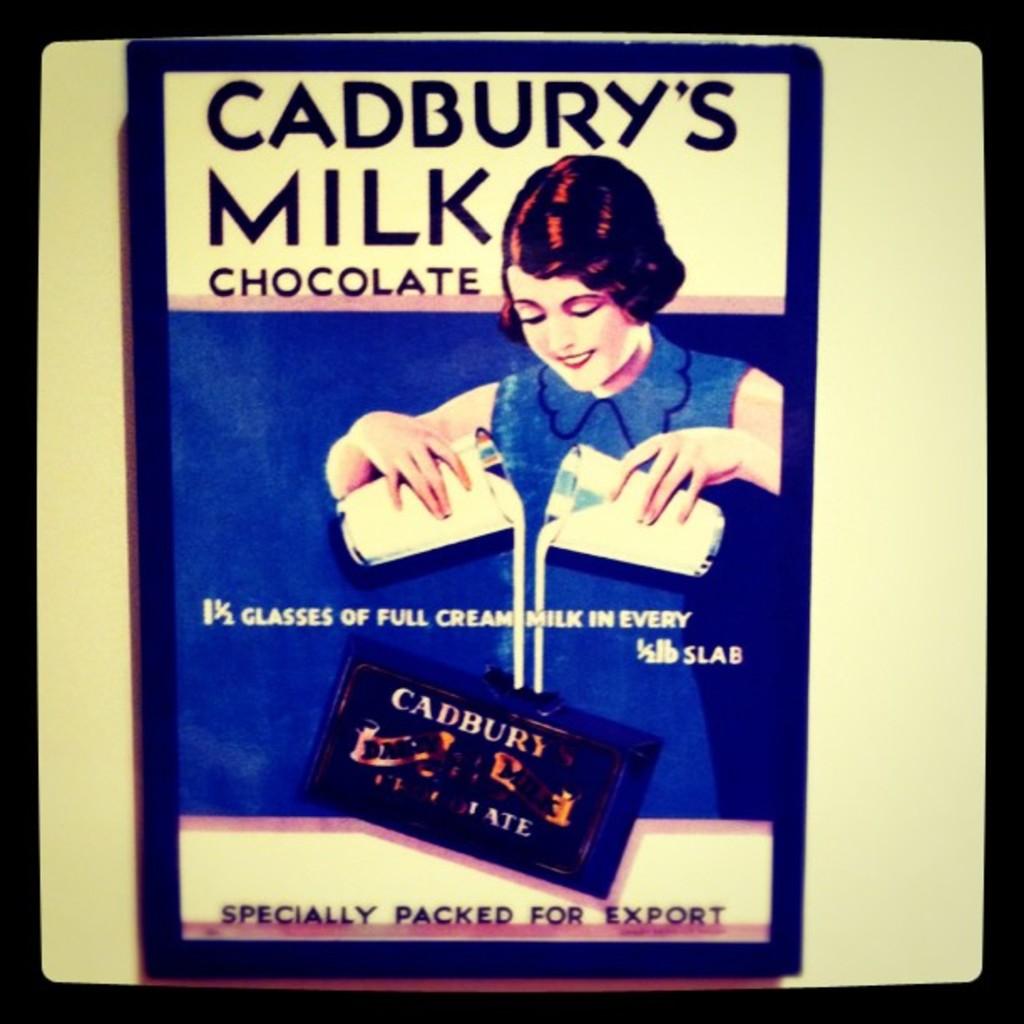What was this chocolate specially packed for?
Offer a terse response. Export. How many glasses is in every slab?
Provide a succinct answer. 1 1/2. 